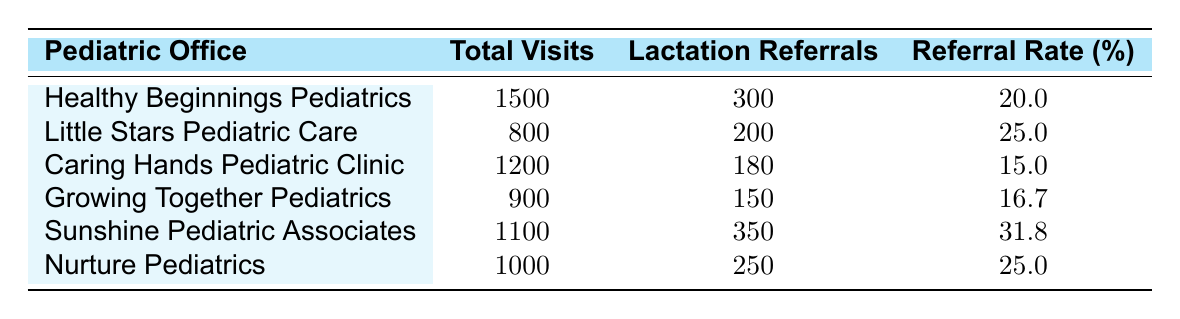What is the referral rate percentage for Sunshine Pediatric Associates? The referral rate percentage for a specific office can be found by looking at the corresponding row. For Sunshine Pediatric Associates, the table shows a referral rate of 31.8%.
Answer: 31.8% Which pediatric office had the highest number of lactation referrals? The highest number of lactation referrals can be determined by comparing the 'Lactation Referrals' column. Sunshine Pediatric Associates leads with 350 referrals.
Answer: Sunshine Pediatric Associates What is the total number of visits across all pediatric offices? To find the total number of visits, we need to sum the 'Total Visits' column. Calculation: 1500 + 800 + 1200 + 900 + 1100 + 1000 = 5700.
Answer: 5700 True or False: Caring Hands Pediatric Clinic has a higher referral rate than Growing Together Pediatrics. Looking at the referral rates, Caring Hands has a rate of 15.0%, and Growing Together has 16.7%. Therefore, the statement is false.
Answer: False What is the average referral rate percentage among all offices? To calculate the average, we first sum the referral rates: (20.0 + 25.0 + 15.0 + 16.7 + 31.8 + 25.0) = 133.5. Then, divide by the number of offices (6): 133.5 / 6 = 22.25.
Answer: 22.25 Which pediatric office has the lowest referral rate percentage? By examining the 'Referral Rate (%)' column, we find that Caring Hands Pediatric Clinic has the lowest rate at 15.0%.
Answer: Caring Hands Pediatric Clinic How many more lactation referrals did Healthy Beginnings Pediatrics have than Caring Hands Pediatric Clinic? To find the difference, subtract the referrals for Caring Hands from Healthy Beginnings: 300 - 180 = 120.
Answer: 120 Which pediatric office had the least total visits last year? By checking the 'Total Visits' column, Little Stars Pediatric Care has the least with 800 visits.
Answer: Little Stars Pediatric Care What percentage of referrals to lactation consultants does Nurture Pediatrics represent out of the total referrals from all offices? First, we find the total referrals: 300 + 200 + 180 + 150 + 350 + 250 = 1430. Then we calculate Nurture's percentage: (250 / 1430) * 100 = 17.48%.
Answer: 17.48% 